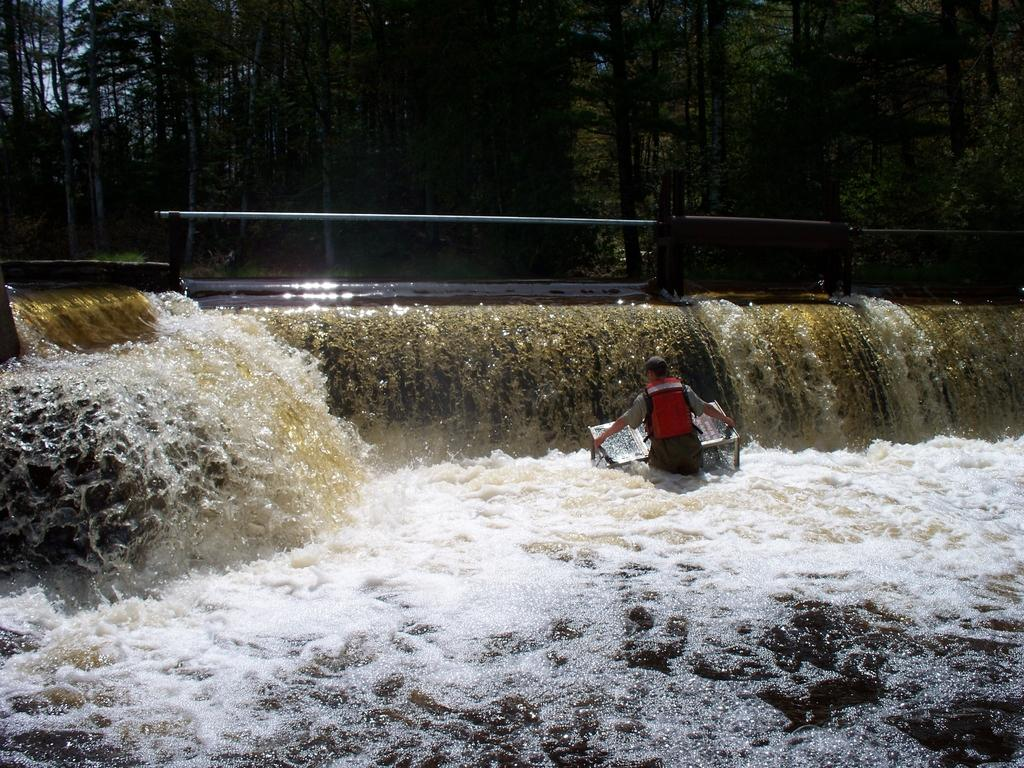What is the man in the image doing? The man is standing in the water. What can be seen in the background of the image? There is a railing and trees in the background of the image. How many crates are stacked next to the man in the image? There are no crates present in the image. What season is depicted in the image, given the presence of spring flowers? There is no mention of spring flowers or any seasonal indicators in the image. 